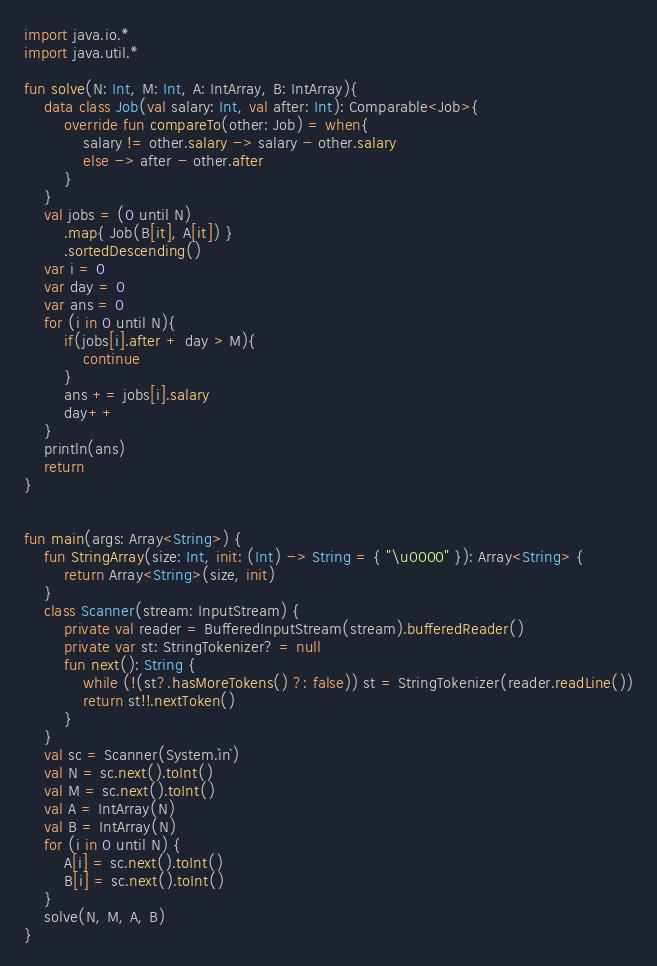Convert code to text. <code><loc_0><loc_0><loc_500><loc_500><_Kotlin_>import java.io.*
import java.util.*

fun solve(N: Int, M: Int, A: IntArray, B: IntArray){
    data class Job(val salary: Int, val after: Int): Comparable<Job>{
        override fun compareTo(other: Job) = when{
            salary != other.salary -> salary - other.salary
            else -> after - other.after
        }
    }
    val jobs = (0 until N)
        .map{ Job(B[it], A[it]) }
        .sortedDescending()
    var i = 0
    var day = 0
    var ans = 0
    for (i in 0 until N){
        if(jobs[i].after + day > M){
            continue
        }
        ans += jobs[i].salary
        day++
    }
    println(ans)
    return
}


fun main(args: Array<String>) {
    fun StringArray(size: Int, init: (Int) -> String = { "\u0000" }): Array<String> {
        return Array<String>(size, init)
    }
    class Scanner(stream: InputStream) {
        private val reader = BufferedInputStream(stream).bufferedReader()
        private var st: StringTokenizer? = null
        fun next(): String {
            while (!(st?.hasMoreTokens() ?: false)) st = StringTokenizer(reader.readLine())
            return st!!.nextToken()
        }
    }
    val sc = Scanner(System.`in`)
    val N = sc.next().toInt()
    val M = sc.next().toInt()
    val A = IntArray(N)
    val B = IntArray(N)
    for (i in 0 until N) {
        A[i] = sc.next().toInt()
        B[i] = sc.next().toInt()
    }
    solve(N, M, A, B)
}

</code> 